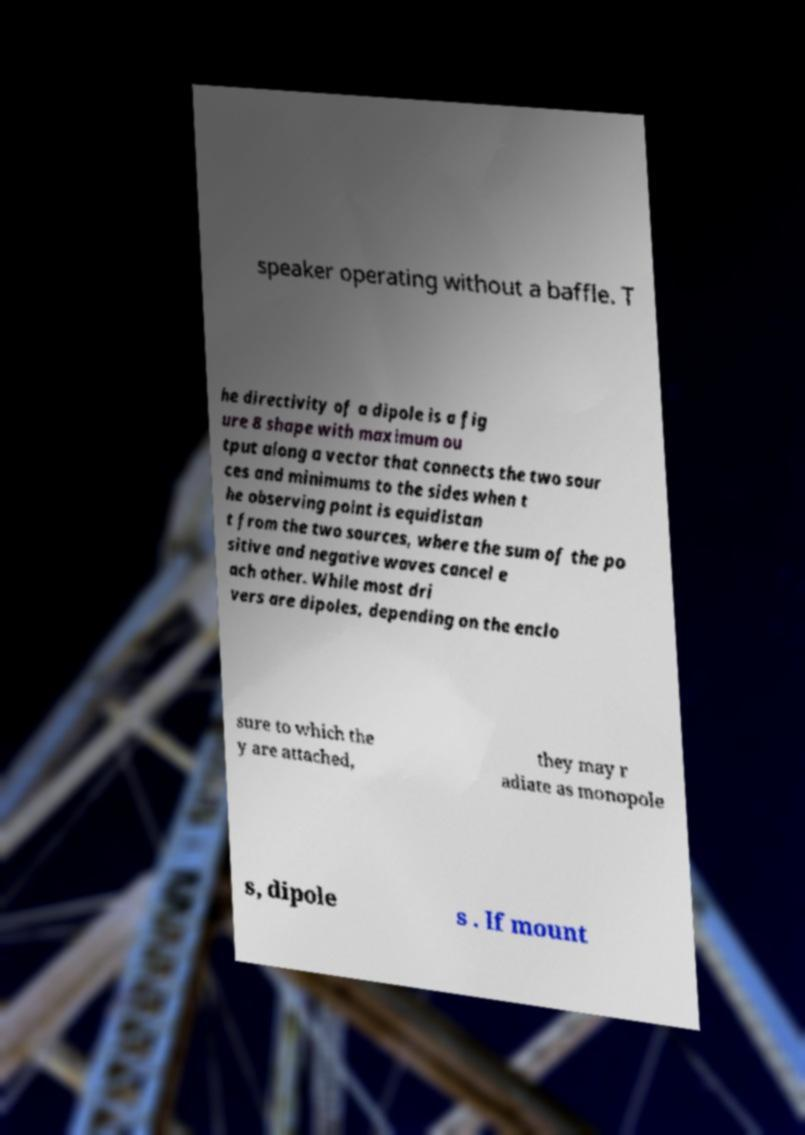I need the written content from this picture converted into text. Can you do that? speaker operating without a baffle. T he directivity of a dipole is a fig ure 8 shape with maximum ou tput along a vector that connects the two sour ces and minimums to the sides when t he observing point is equidistan t from the two sources, where the sum of the po sitive and negative waves cancel e ach other. While most dri vers are dipoles, depending on the enclo sure to which the y are attached, they may r adiate as monopole s, dipole s . If mount 